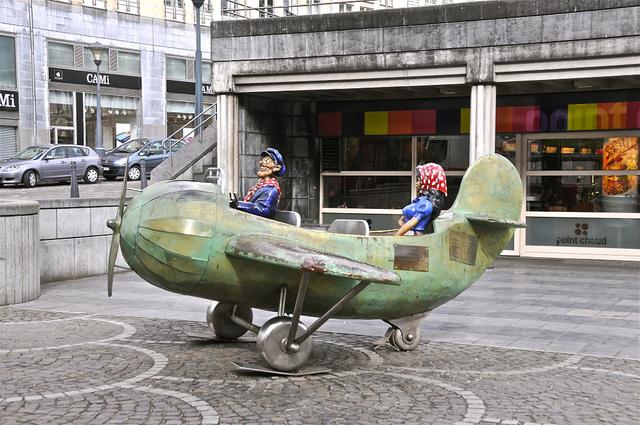Is the plane a toy?
Concise answer only. Yes. Are the people real?
Quick response, please. No. How many people are in the plane?
Quick response, please. 2. 